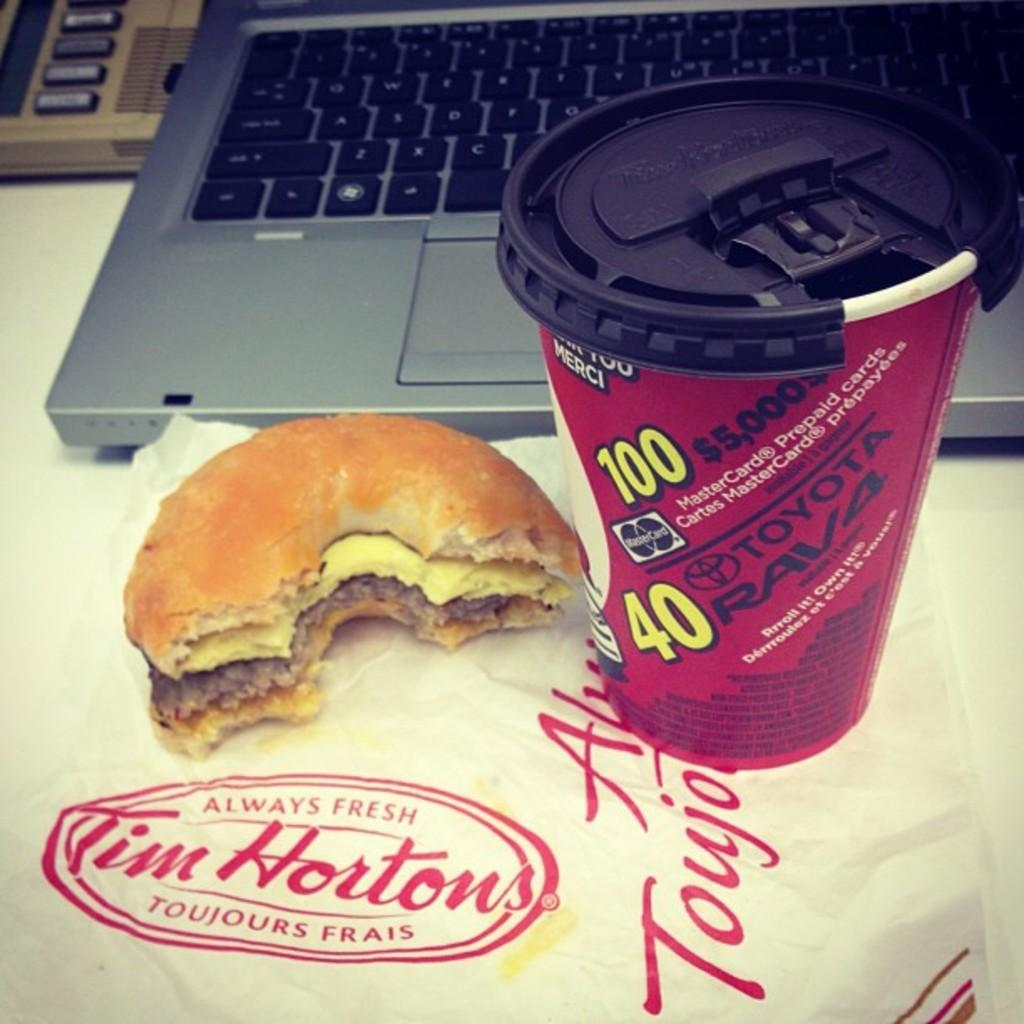What electronic device is visible in the image? There is a laptop in the image. What else can be seen in the image besides the laptop? There are food items, a glass, and posters with text visible in the image. Can you describe the posters with text in the image? The posters with text are in the image, but their content is not discernible. What object is located in the top left corner of the image? There is an object in the top left corner of the image, but its identity cannot be determined from the provided facts. What type of chicken is being cooked in the image? There is no chicken present in the image; it only contains food items, but their specific types are not discernible. 